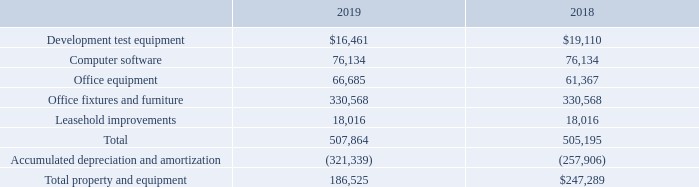NOTE E – PROPERTY AND EQUIPMENT
The Company’s property and equipment as of December 31, 2019 and 2018 consists of the following:
Depreciation and amortization expense included as a charge to income was $66,082 and $67,107 for the years ended December 31, 2019 and 2018, respectively.
What are the types of property and equipment? Development test equipment, computer software, office equipment, office fixtures and furniture, leasehold improvements. What is the total property and equipment for the year ended December 31, 2019? 186,525. What is the depreciation and amortization expenses for the year ended December 31, 2019? $66,082. Which year has a higher total value of property and equipment? Find and compare the total property and equipment across the two years
Answer: 2018. What is the percentage change in the value of computer software from 2018 to 2019?
Answer scale should be: percent. (76,134-76,134)/76,134
Answer: 0. What is the percentage change in the Depreciation and amortization expense from 2018 to 2019?
Answer scale should be: percent. (66,082-67,107)/67,107
Answer: -1.53. 